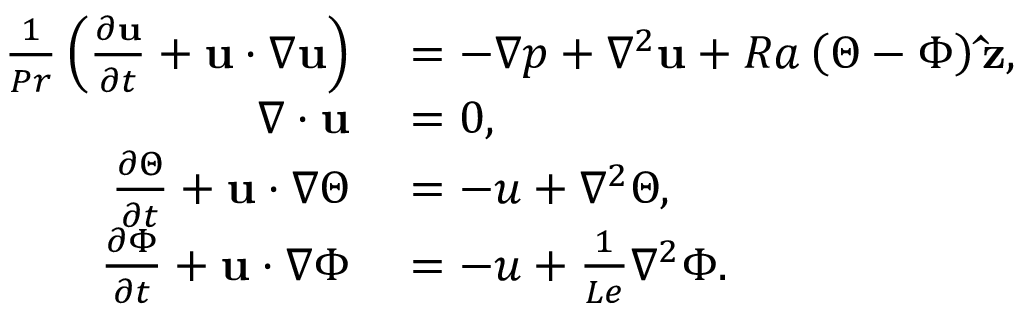<formula> <loc_0><loc_0><loc_500><loc_500>\begin{array} { r l } { \frac { 1 } { P r } \left ( \frac { \partial u } { \partial t } + u \cdot \nabla u \right ) } & = - \nabla p + \nabla ^ { 2 } u + R a \left ( \Theta - \Phi \right ) \hat { z } , } \\ { \nabla \cdot u } & = 0 , } \\ { \frac { \partial \Theta } { \partial t } + u \cdot \nabla \Theta } & = - u + \nabla ^ { 2 } \Theta , } \\ { \frac { \partial \Phi } { \partial t } + u \cdot \nabla \Phi } & = - u + \frac { 1 } { L e } \nabla ^ { 2 } \Phi . } \end{array}</formula> 